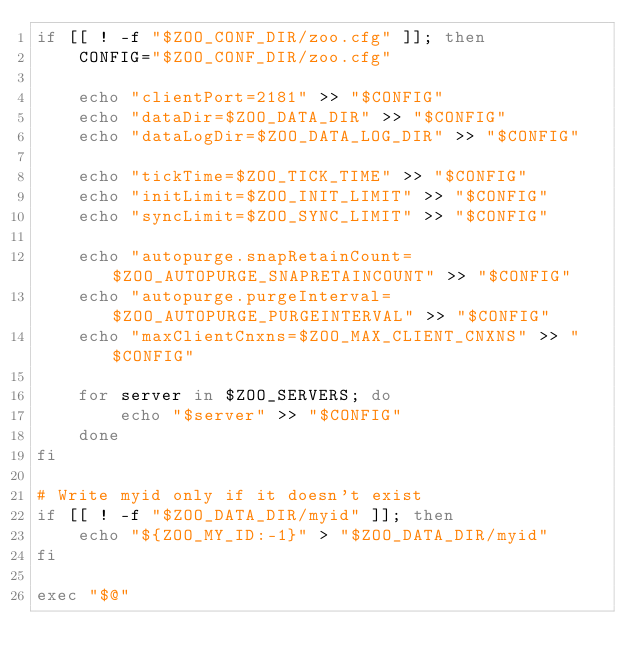Convert code to text. <code><loc_0><loc_0><loc_500><loc_500><_Bash_>if [[ ! -f "$ZOO_CONF_DIR/zoo.cfg" ]]; then
    CONFIG="$ZOO_CONF_DIR/zoo.cfg"

    echo "clientPort=2181" >> "$CONFIG"
    echo "dataDir=$ZOO_DATA_DIR" >> "$CONFIG"
    echo "dataLogDir=$ZOO_DATA_LOG_DIR" >> "$CONFIG"

    echo "tickTime=$ZOO_TICK_TIME" >> "$CONFIG"
    echo "initLimit=$ZOO_INIT_LIMIT" >> "$CONFIG"
    echo "syncLimit=$ZOO_SYNC_LIMIT" >> "$CONFIG"

    echo "autopurge.snapRetainCount=$ZOO_AUTOPURGE_SNAPRETAINCOUNT" >> "$CONFIG"
    echo "autopurge.purgeInterval=$ZOO_AUTOPURGE_PURGEINTERVAL" >> "$CONFIG"
    echo "maxClientCnxns=$ZOO_MAX_CLIENT_CNXNS" >> "$CONFIG"

    for server in $ZOO_SERVERS; do
        echo "$server" >> "$CONFIG"
    done
fi

# Write myid only if it doesn't exist
if [[ ! -f "$ZOO_DATA_DIR/myid" ]]; then
    echo "${ZOO_MY_ID:-1}" > "$ZOO_DATA_DIR/myid"
fi

exec "$@"
</code> 